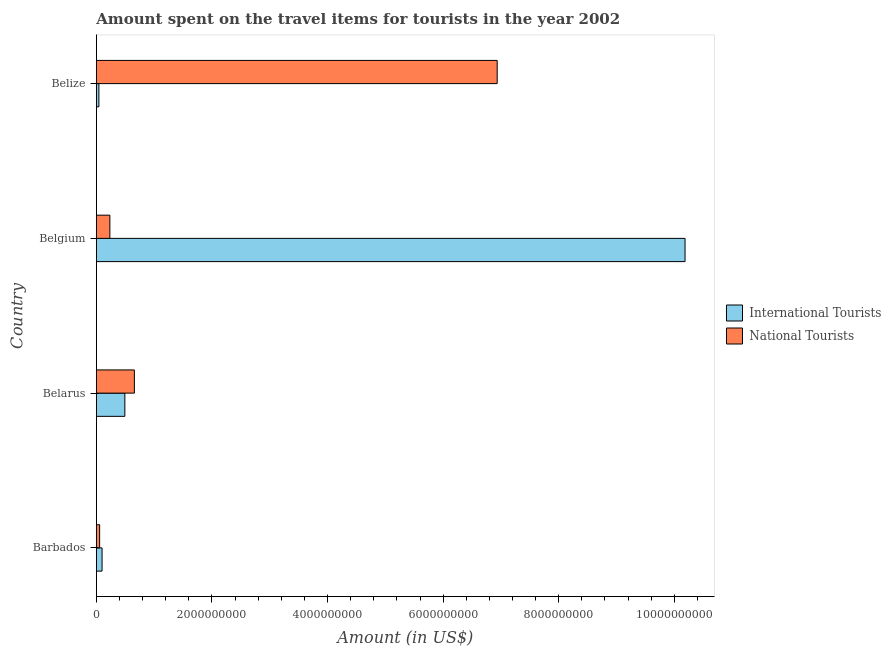How many different coloured bars are there?
Provide a short and direct response. 2. How many bars are there on the 2nd tick from the top?
Give a very brief answer. 2. How many bars are there on the 1st tick from the bottom?
Provide a short and direct response. 2. What is the label of the 2nd group of bars from the top?
Your answer should be compact. Belgium. What is the amount spent on travel items of international tourists in Belarus?
Provide a short and direct response. 4.93e+08. Across all countries, what is the maximum amount spent on travel items of national tourists?
Your answer should be compact. 6.94e+09. Across all countries, what is the minimum amount spent on travel items of international tourists?
Your response must be concise. 4.40e+07. In which country was the amount spent on travel items of national tourists maximum?
Your response must be concise. Belize. In which country was the amount spent on travel items of national tourists minimum?
Provide a short and direct response. Barbados. What is the total amount spent on travel items of national tourists in the graph?
Give a very brief answer. 7.88e+09. What is the difference between the amount spent on travel items of international tourists in Belgium and that in Belize?
Offer a very short reply. 1.01e+1. What is the difference between the amount spent on travel items of national tourists in Belarus and the amount spent on travel items of international tourists in Belize?
Your answer should be compact. 6.14e+08. What is the average amount spent on travel items of international tourists per country?
Keep it short and to the point. 2.71e+09. What is the difference between the amount spent on travel items of national tourists and amount spent on travel items of international tourists in Belize?
Offer a very short reply. 6.89e+09. In how many countries, is the amount spent on travel items of international tourists greater than 400000000 US$?
Your answer should be very brief. 2. What is the ratio of the amount spent on travel items of international tourists in Barbados to that in Belgium?
Offer a terse response. 0.01. Is the amount spent on travel items of international tourists in Belarus less than that in Belize?
Provide a succinct answer. No. What is the difference between the highest and the second highest amount spent on travel items of international tourists?
Keep it short and to the point. 9.69e+09. What is the difference between the highest and the lowest amount spent on travel items of national tourists?
Keep it short and to the point. 6.88e+09. In how many countries, is the amount spent on travel items of international tourists greater than the average amount spent on travel items of international tourists taken over all countries?
Your answer should be compact. 1. Is the sum of the amount spent on travel items of national tourists in Barbados and Belarus greater than the maximum amount spent on travel items of international tourists across all countries?
Offer a terse response. No. What does the 1st bar from the top in Belize represents?
Offer a terse response. National Tourists. What does the 1st bar from the bottom in Barbados represents?
Keep it short and to the point. International Tourists. How many bars are there?
Provide a short and direct response. 8. Does the graph contain any zero values?
Your answer should be very brief. No. What is the title of the graph?
Provide a short and direct response. Amount spent on the travel items for tourists in the year 2002. Does "Largest city" appear as one of the legend labels in the graph?
Offer a very short reply. No. What is the Amount (in US$) in International Tourists in Barbados?
Make the answer very short. 9.90e+07. What is the Amount (in US$) of National Tourists in Barbados?
Make the answer very short. 5.70e+07. What is the Amount (in US$) of International Tourists in Belarus?
Provide a short and direct response. 4.93e+08. What is the Amount (in US$) in National Tourists in Belarus?
Offer a very short reply. 6.58e+08. What is the Amount (in US$) in International Tourists in Belgium?
Offer a terse response. 1.02e+1. What is the Amount (in US$) of National Tourists in Belgium?
Provide a short and direct response. 2.34e+08. What is the Amount (in US$) of International Tourists in Belize?
Keep it short and to the point. 4.40e+07. What is the Amount (in US$) of National Tourists in Belize?
Your answer should be compact. 6.94e+09. Across all countries, what is the maximum Amount (in US$) of International Tourists?
Ensure brevity in your answer.  1.02e+1. Across all countries, what is the maximum Amount (in US$) in National Tourists?
Provide a succinct answer. 6.94e+09. Across all countries, what is the minimum Amount (in US$) of International Tourists?
Your answer should be compact. 4.40e+07. Across all countries, what is the minimum Amount (in US$) in National Tourists?
Provide a succinct answer. 5.70e+07. What is the total Amount (in US$) of International Tourists in the graph?
Your answer should be compact. 1.08e+1. What is the total Amount (in US$) of National Tourists in the graph?
Your answer should be very brief. 7.88e+09. What is the difference between the Amount (in US$) in International Tourists in Barbados and that in Belarus?
Provide a succinct answer. -3.94e+08. What is the difference between the Amount (in US$) in National Tourists in Barbados and that in Belarus?
Offer a very short reply. -6.01e+08. What is the difference between the Amount (in US$) in International Tourists in Barbados and that in Belgium?
Make the answer very short. -1.01e+1. What is the difference between the Amount (in US$) of National Tourists in Barbados and that in Belgium?
Offer a very short reply. -1.77e+08. What is the difference between the Amount (in US$) in International Tourists in Barbados and that in Belize?
Offer a very short reply. 5.50e+07. What is the difference between the Amount (in US$) in National Tourists in Barbados and that in Belize?
Ensure brevity in your answer.  -6.88e+09. What is the difference between the Amount (in US$) in International Tourists in Belarus and that in Belgium?
Provide a succinct answer. -9.69e+09. What is the difference between the Amount (in US$) in National Tourists in Belarus and that in Belgium?
Your answer should be compact. 4.24e+08. What is the difference between the Amount (in US$) of International Tourists in Belarus and that in Belize?
Make the answer very short. 4.49e+08. What is the difference between the Amount (in US$) in National Tourists in Belarus and that in Belize?
Your response must be concise. -6.28e+09. What is the difference between the Amount (in US$) of International Tourists in Belgium and that in Belize?
Make the answer very short. 1.01e+1. What is the difference between the Amount (in US$) in National Tourists in Belgium and that in Belize?
Your answer should be compact. -6.70e+09. What is the difference between the Amount (in US$) in International Tourists in Barbados and the Amount (in US$) in National Tourists in Belarus?
Ensure brevity in your answer.  -5.59e+08. What is the difference between the Amount (in US$) of International Tourists in Barbados and the Amount (in US$) of National Tourists in Belgium?
Your answer should be very brief. -1.35e+08. What is the difference between the Amount (in US$) of International Tourists in Barbados and the Amount (in US$) of National Tourists in Belize?
Make the answer very short. -6.84e+09. What is the difference between the Amount (in US$) in International Tourists in Belarus and the Amount (in US$) in National Tourists in Belgium?
Give a very brief answer. 2.59e+08. What is the difference between the Amount (in US$) in International Tourists in Belarus and the Amount (in US$) in National Tourists in Belize?
Offer a terse response. -6.44e+09. What is the difference between the Amount (in US$) in International Tourists in Belgium and the Amount (in US$) in National Tourists in Belize?
Provide a short and direct response. 3.25e+09. What is the average Amount (in US$) in International Tourists per country?
Your answer should be compact. 2.71e+09. What is the average Amount (in US$) of National Tourists per country?
Give a very brief answer. 1.97e+09. What is the difference between the Amount (in US$) in International Tourists and Amount (in US$) in National Tourists in Barbados?
Your response must be concise. 4.20e+07. What is the difference between the Amount (in US$) of International Tourists and Amount (in US$) of National Tourists in Belarus?
Offer a terse response. -1.65e+08. What is the difference between the Amount (in US$) of International Tourists and Amount (in US$) of National Tourists in Belgium?
Provide a succinct answer. 9.95e+09. What is the difference between the Amount (in US$) of International Tourists and Amount (in US$) of National Tourists in Belize?
Ensure brevity in your answer.  -6.89e+09. What is the ratio of the Amount (in US$) of International Tourists in Barbados to that in Belarus?
Provide a succinct answer. 0.2. What is the ratio of the Amount (in US$) of National Tourists in Barbados to that in Belarus?
Give a very brief answer. 0.09. What is the ratio of the Amount (in US$) in International Tourists in Barbados to that in Belgium?
Your response must be concise. 0.01. What is the ratio of the Amount (in US$) of National Tourists in Barbados to that in Belgium?
Make the answer very short. 0.24. What is the ratio of the Amount (in US$) in International Tourists in Barbados to that in Belize?
Offer a very short reply. 2.25. What is the ratio of the Amount (in US$) in National Tourists in Barbados to that in Belize?
Give a very brief answer. 0.01. What is the ratio of the Amount (in US$) of International Tourists in Belarus to that in Belgium?
Your answer should be compact. 0.05. What is the ratio of the Amount (in US$) of National Tourists in Belarus to that in Belgium?
Your answer should be compact. 2.81. What is the ratio of the Amount (in US$) in International Tourists in Belarus to that in Belize?
Offer a very short reply. 11.2. What is the ratio of the Amount (in US$) of National Tourists in Belarus to that in Belize?
Provide a succinct answer. 0.09. What is the ratio of the Amount (in US$) in International Tourists in Belgium to that in Belize?
Offer a terse response. 231.48. What is the ratio of the Amount (in US$) in National Tourists in Belgium to that in Belize?
Provide a short and direct response. 0.03. What is the difference between the highest and the second highest Amount (in US$) of International Tourists?
Provide a short and direct response. 9.69e+09. What is the difference between the highest and the second highest Amount (in US$) in National Tourists?
Provide a short and direct response. 6.28e+09. What is the difference between the highest and the lowest Amount (in US$) in International Tourists?
Offer a terse response. 1.01e+1. What is the difference between the highest and the lowest Amount (in US$) in National Tourists?
Ensure brevity in your answer.  6.88e+09. 